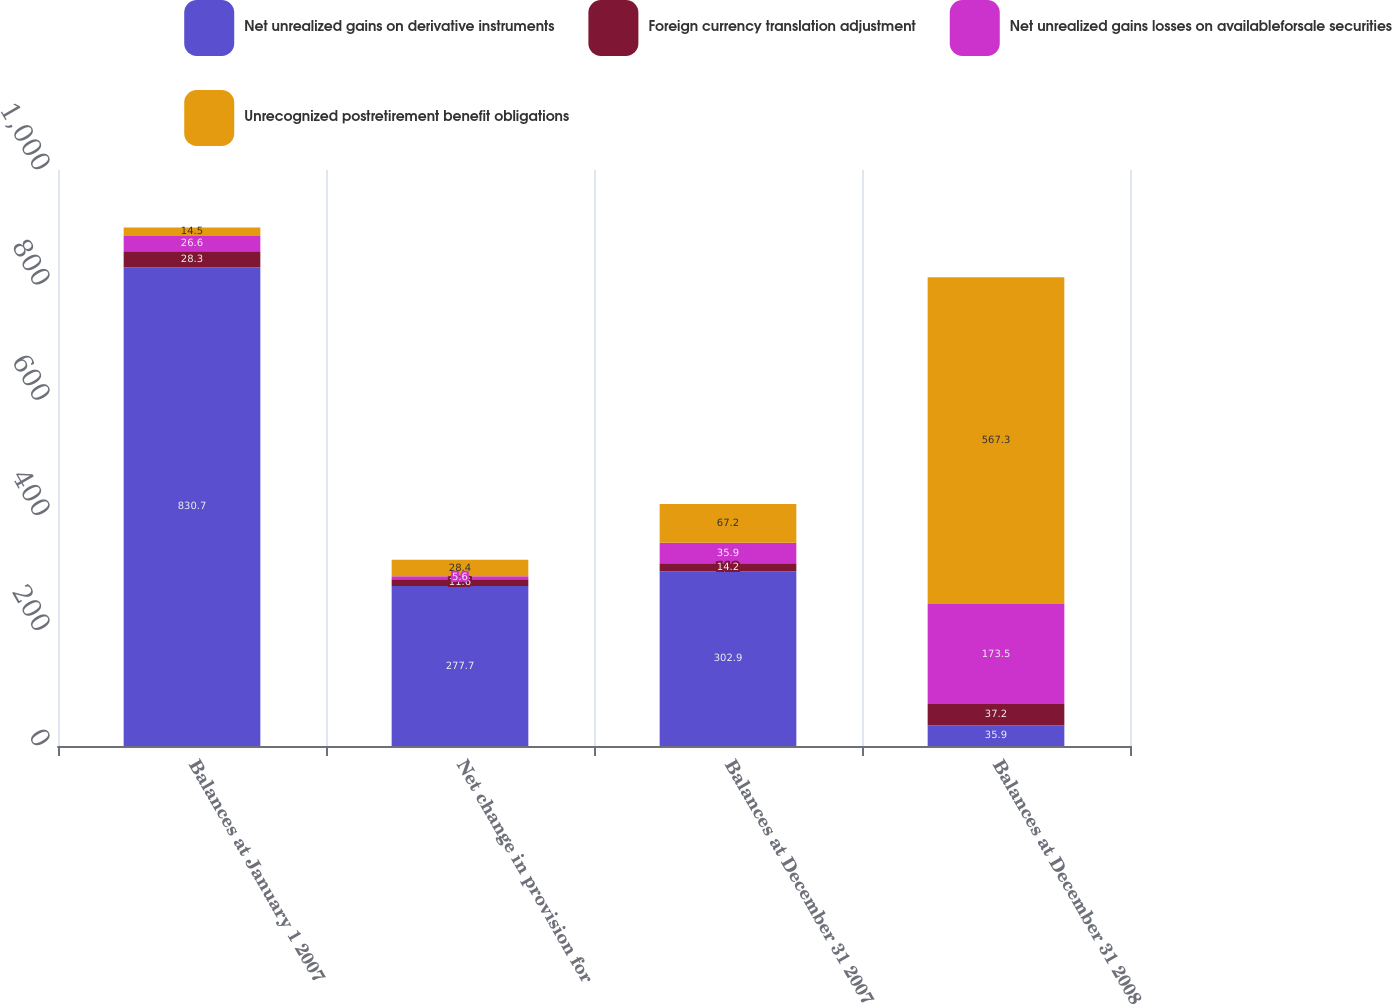Convert chart to OTSL. <chart><loc_0><loc_0><loc_500><loc_500><stacked_bar_chart><ecel><fcel>Balances at January 1 2007<fcel>Net change in provision for<fcel>Balances at December 31 2007<fcel>Balances at December 31 2008<nl><fcel>Net unrealized gains on derivative instruments<fcel>830.7<fcel>277.7<fcel>302.9<fcel>35.9<nl><fcel>Foreign currency translation adjustment<fcel>28.3<fcel>11.6<fcel>14.2<fcel>37.2<nl><fcel>Net unrealized gains losses on availableforsale securities<fcel>26.6<fcel>5.6<fcel>35.9<fcel>173.5<nl><fcel>Unrecognized postretirement benefit obligations<fcel>14.5<fcel>28.4<fcel>67.2<fcel>567.3<nl></chart> 